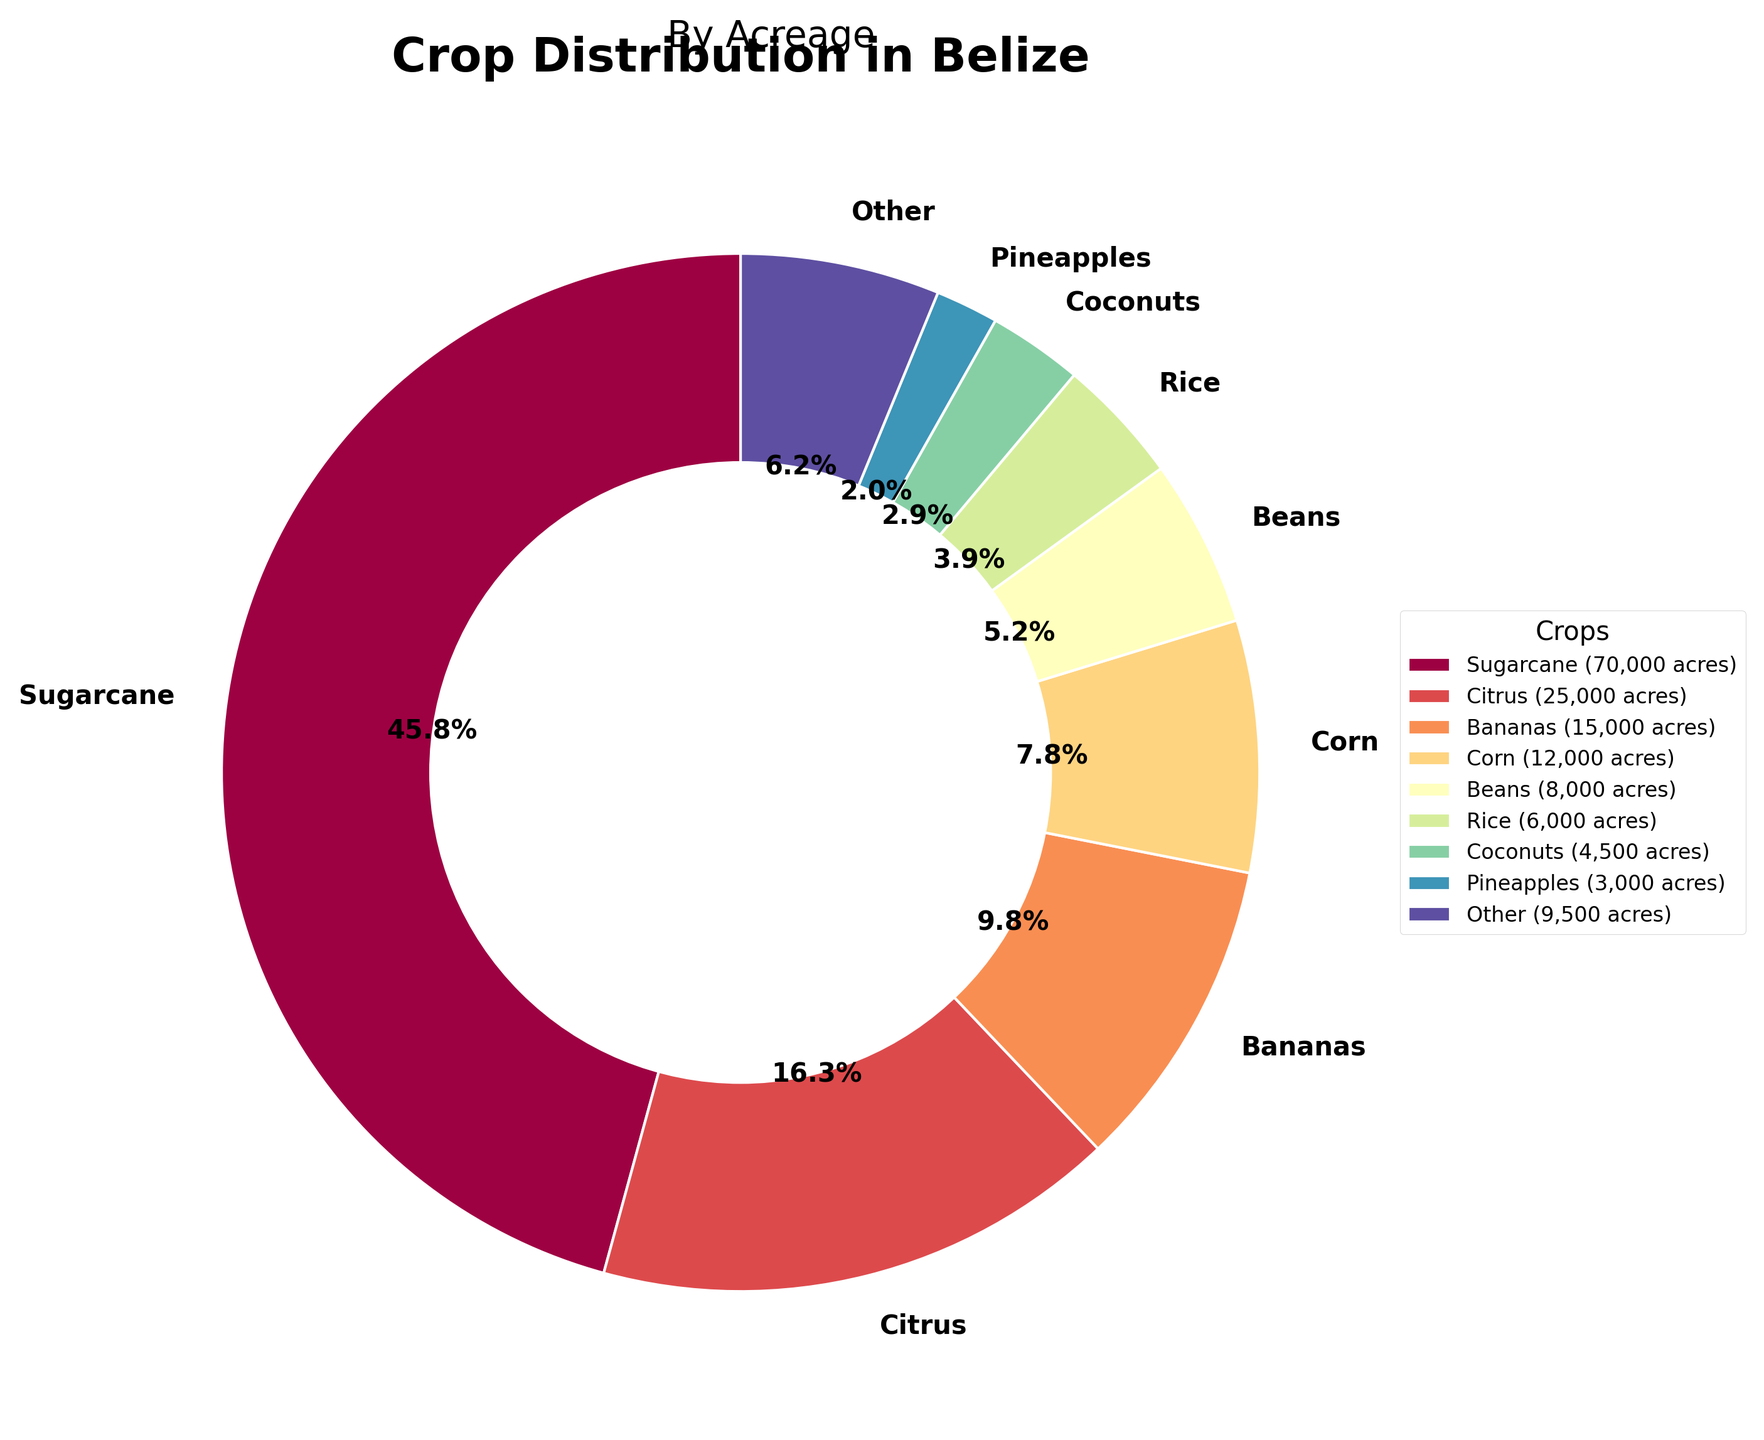what percentage of the total acreage do sugarcane and citrus together account for? Sugarcane accounts for 46.7% and Citrus for 16.7%. Adding these percentages together, 46.7% + 16.7% = 63.4%.
Answer: 63.4% which crop has the smallest acreage? From the figure, Avocados is the crop with the smallest acreage.
Answer: Avocados how much larger is the acreage of sugarcane compared to rice? Sugarcane has 70,000 acres, and Rice has 6,000 acres. The difference is 70,000 - 6,000 = 64,000 acres.
Answer: 64,000 acres what is the combined percentage of Bananas, Corn, and Beans? Bananas account for 10.0%, Corn for 8.0%, and Beans for 5.3%. Adding these percentages together, 10.0% + 8.0% + 5.3% = 23.3%.
Answer: 23.3% what color wedge represents the crop with the second highest acreage? The crop with the second highest acreage is Citrus. The wedge representing Citrus is orange in the pie chart.
Answer: Orange how many crops are grouped under "Other"? The figure groups all crops beyond the top 8 into "Other". The crops included are Pineapples, Papayas, Cacao, Plantains, Soybeans, Sorghum, Cashews, and Avocados. There are 8 crops in "Other".
Answer: 8 what is the difference in percentage between the crop with the highest acreage and the crop with the lowest acreage? Sugarcane has the highest acreage at 46.7%, and Avocados have the lowest at 0.3%. The percentage difference is 46.7% - 0.3% = 46.4%.
Answer: 46.4% which two crops have an acreage difference closest to 2,500 acres? The acreages of Papayas (2,500) and Cacao (2,000) have a difference of 500 acres.
Answer: Papayas and Cacao what is the average acreage of the top 3 crops? The top 3 crops by acreage are Sugarcane (70,000), Citrus (25,000), and Bananas (15,000). The average is (70,000 + 25,000 + 15,000) / 3 = 110,000 / 3 ≈ 36,667 acres.
Answer: 36,667 acres 